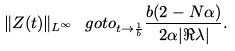<formula> <loc_0><loc_0><loc_500><loc_500>\| Z ( t ) \| _ { L ^ { \infty } } \ g o t o _ { t \to \frac { 1 } { b } } \frac { b ( 2 - N \alpha ) } { 2 \alpha | \Re \lambda | } .</formula> 